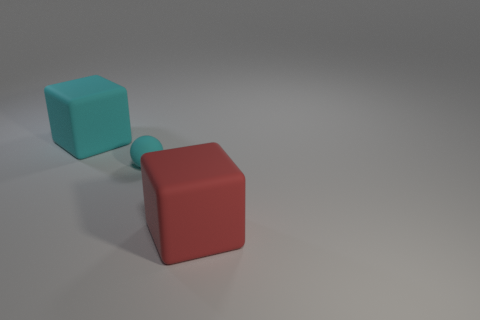What can you infer about the texture on the surfaces of these objects? The surfaces of the cubes appear to be smooth with a slight matte finish, which diffuses the light and minimizes any reflective glare. This indicates a lack of significant texture and suggests a softness associated with rubber material. 